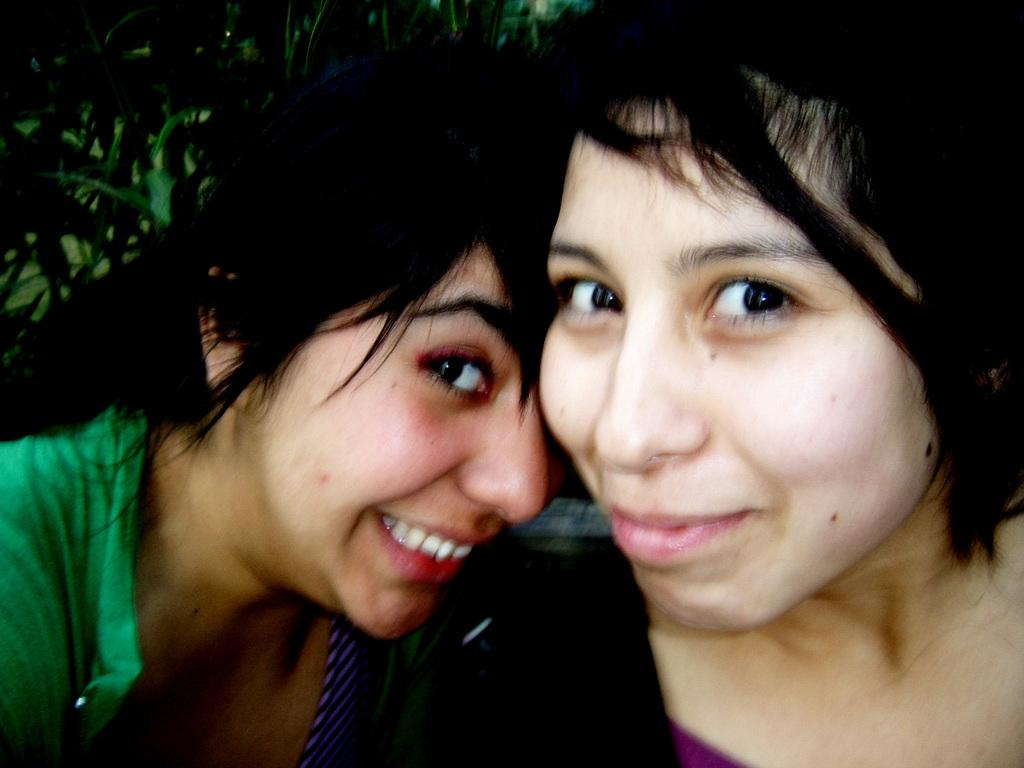Where was the image taken? The image was taken outdoors. What can be seen in the background of the image? There is a tree in the background of the image. How many people are in the image? There are two women in the middle of the image. What is the facial expression of the women in the image? The women have smiling faces. What type of baseball equipment can be seen in the image? There is no baseball equipment present in the image. Is the donkey in the image moving or standing still? There is no donkey present in the image. 